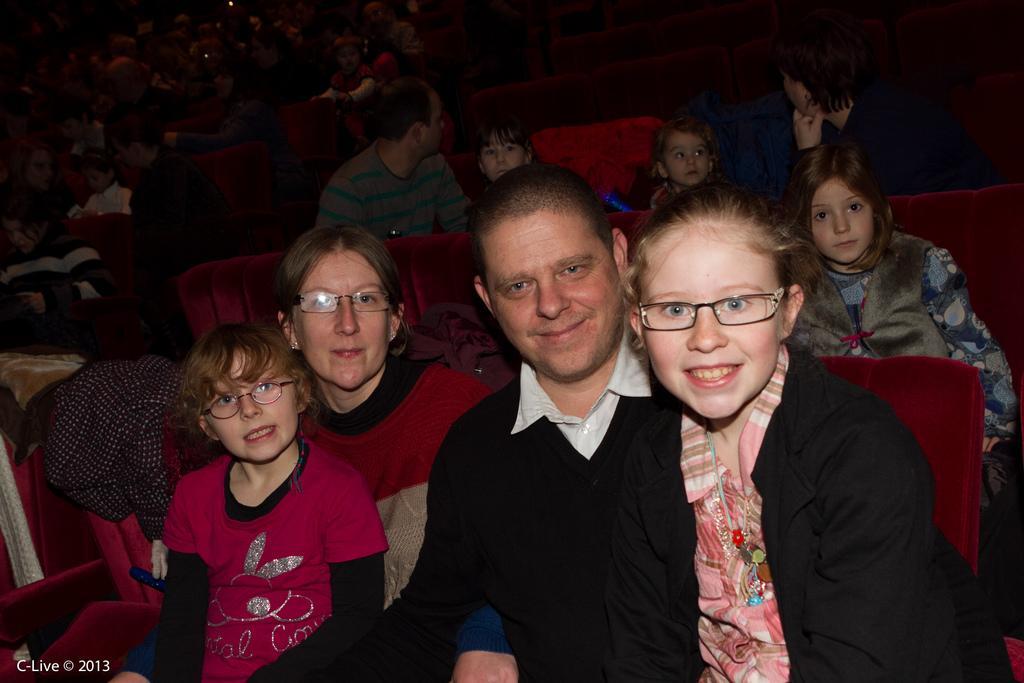Please provide a concise description of this image. In this image we can see a group of people sitting on the chairs. In that we can see two children sitting on the lap of a man and a woman. On the left side we can see a cloth and some text. 